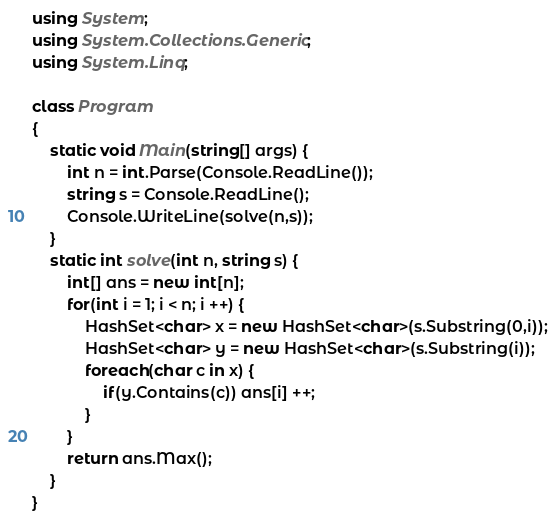<code> <loc_0><loc_0><loc_500><loc_500><_C#_>using System;
using System.Collections.Generic;
using System.Linq;

class Program
{
    static void Main(string[] args) {
        int n = int.Parse(Console.ReadLine());
        string s = Console.ReadLine();
        Console.WriteLine(solve(n,s));
    }
    static int solve(int n, string s) {
        int[] ans = new int[n];
        for(int i = 1; i < n; i ++) {
            HashSet<char> x = new HashSet<char>(s.Substring(0,i));
            HashSet<char> y = new HashSet<char>(s.Substring(i));
            foreach(char c in x) {
                if(y.Contains(c)) ans[i] ++;
            }
        }
        return ans.Max();
    }
}</code> 